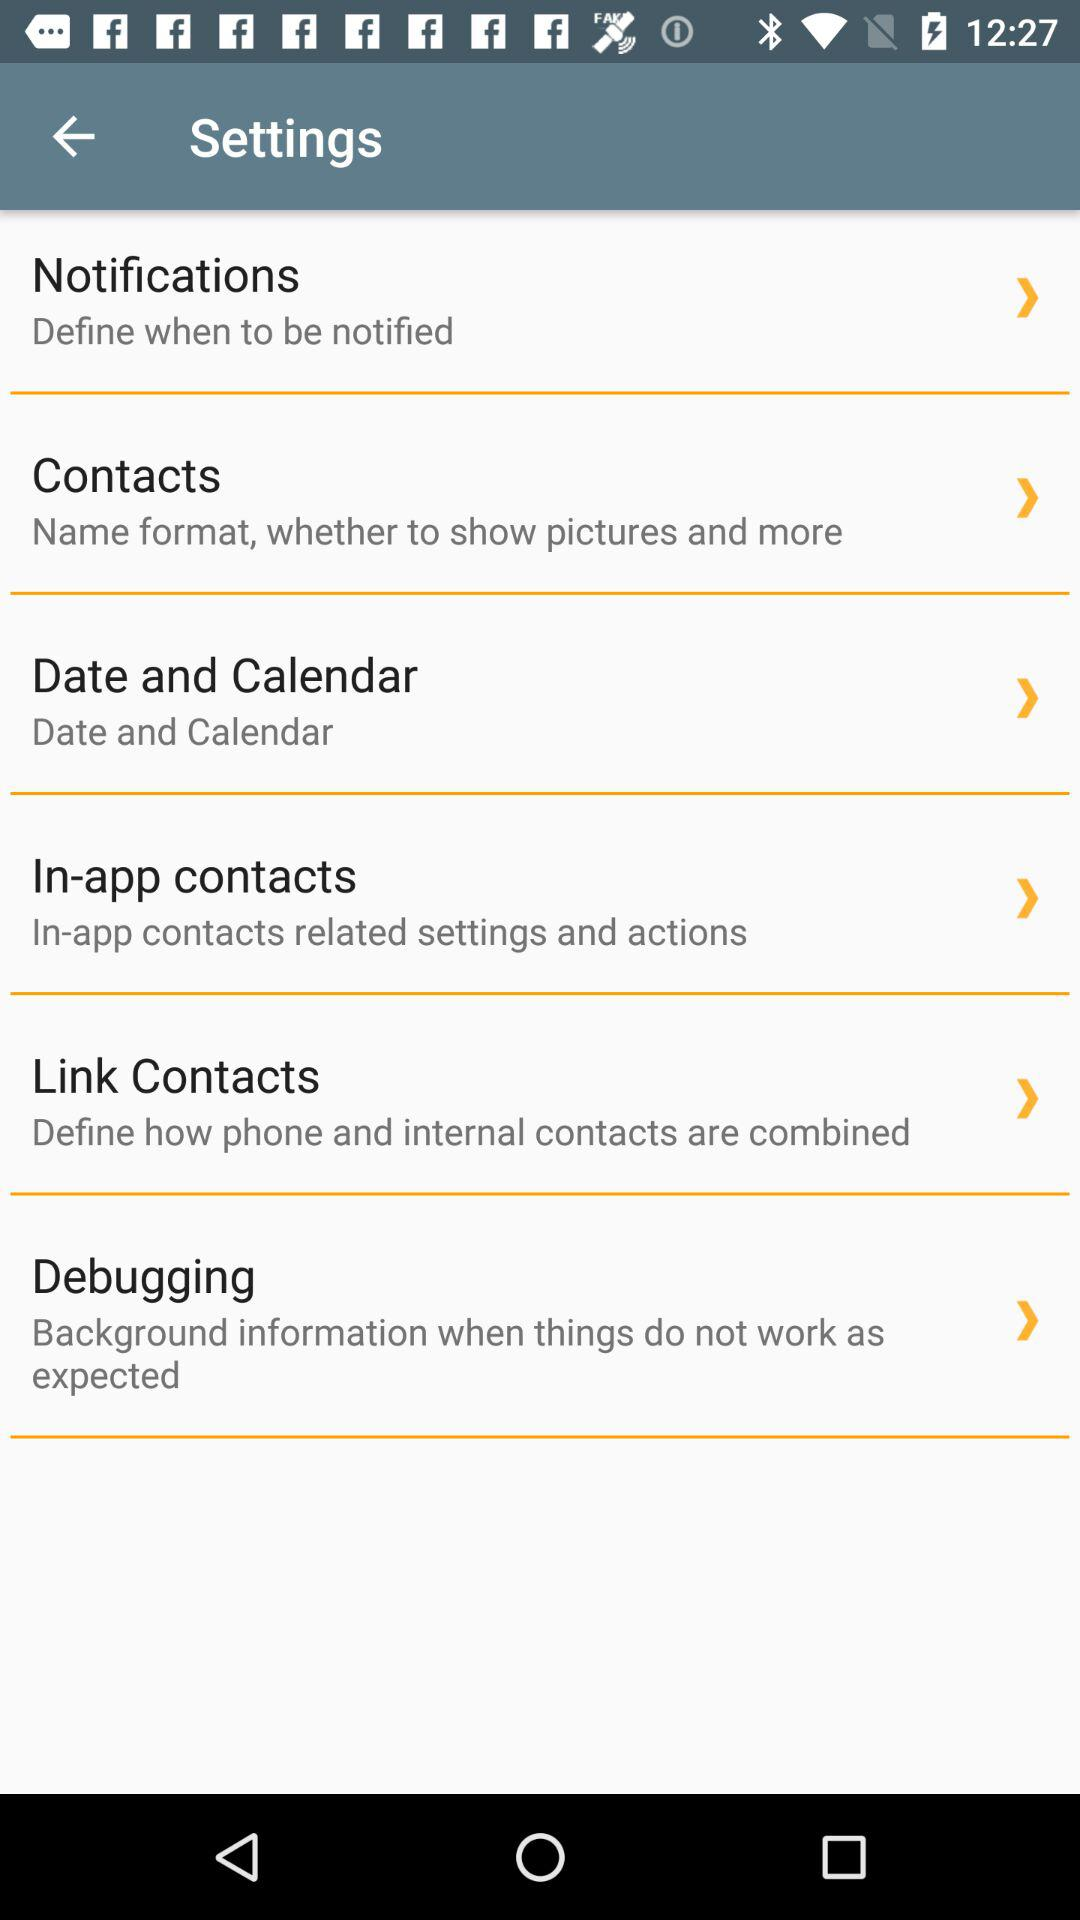How many items are there in the settings menu?
Answer the question using a single word or phrase. 6 